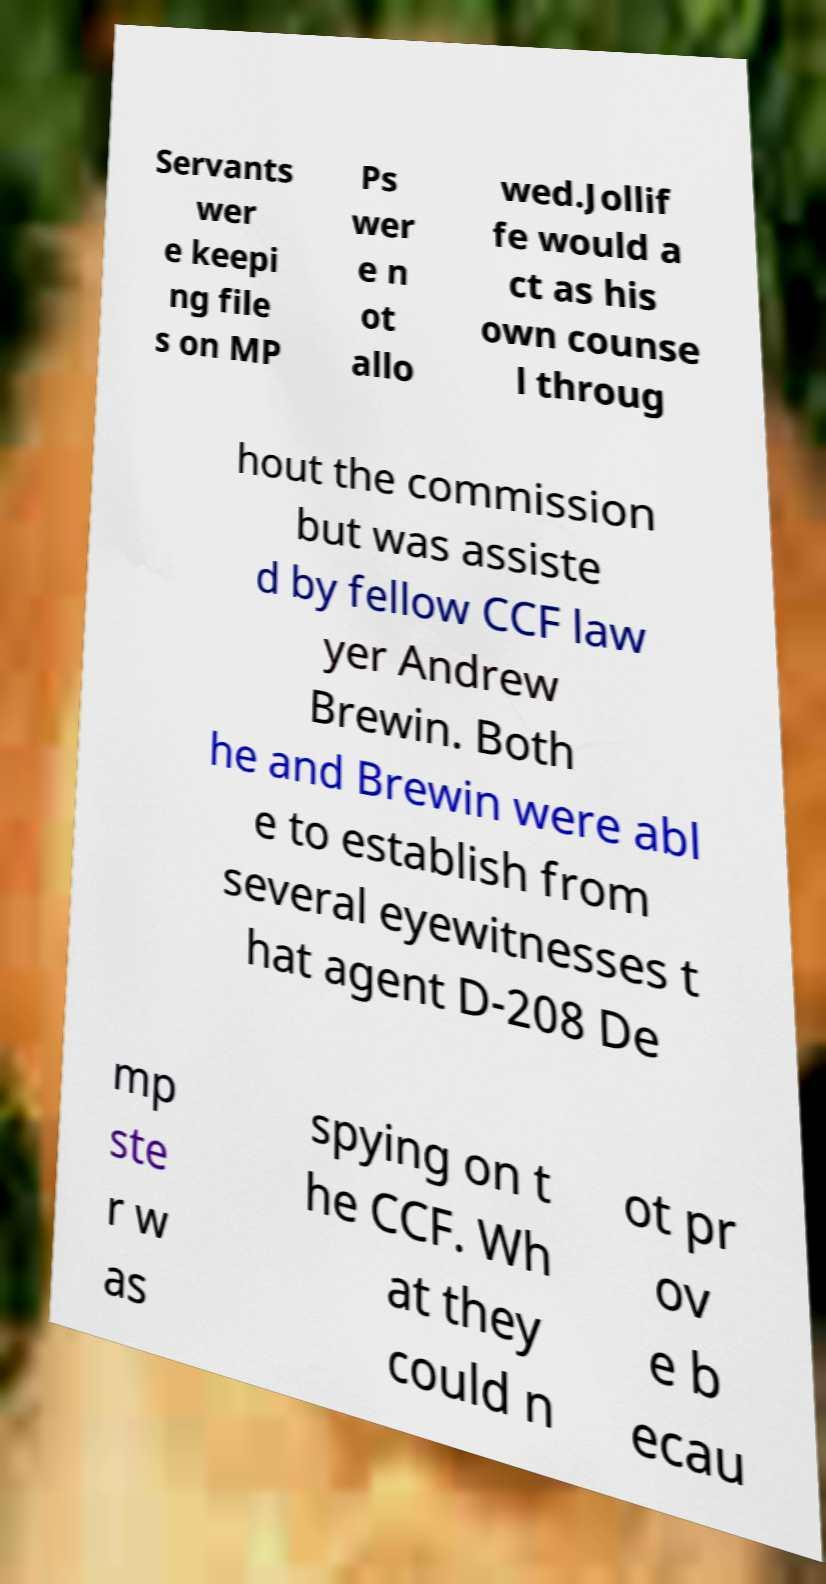Please read and relay the text visible in this image. What does it say? Servants wer e keepi ng file s on MP Ps wer e n ot allo wed.Jollif fe would a ct as his own counse l throug hout the commission but was assiste d by fellow CCF law yer Andrew Brewin. Both he and Brewin were abl e to establish from several eyewitnesses t hat agent D-208 De mp ste r w as spying on t he CCF. Wh at they could n ot pr ov e b ecau 